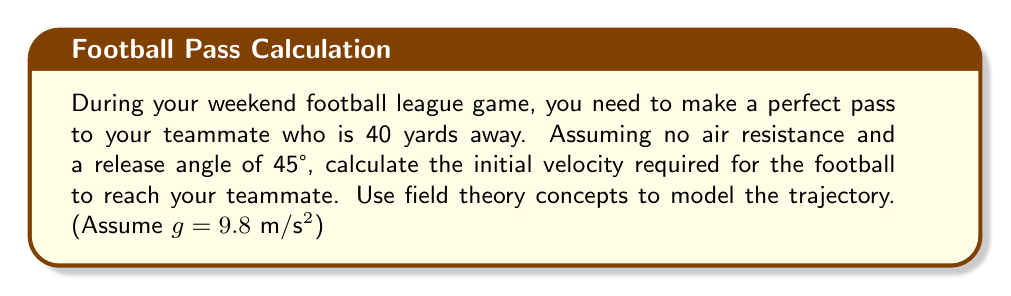Provide a solution to this math problem. Let's approach this step-by-step using field theory concepts:

1) The trajectory of the football can be modeled as a projectile motion in a uniform gravitational field. The equations of motion are:

   $$x(t) = v_0 \cos(\theta) t$$
   $$y(t) = v_0 \sin(\theta) t - \frac{1}{2}gt^2$$

   Where $v_0$ is the initial velocity, $\theta$ is the launch angle, and $t$ is time.

2) We're given that $\theta = 45°$ and the horizontal distance is 40 yards (36.576 meters).

3) For a 45° angle, $\cos(\theta) = \sin(\theta) = \frac{1}{\sqrt{2}}$

4) We need to find the time it takes for the ball to reach its target. Using the horizontal equation:

   $$36.576 = v_0 \cdot \frac{1}{\sqrt{2}} \cdot t$$

5) Solve for $t$:

   $$t = \frac{36.576 \cdot \sqrt{2}}{v_0}$$

6) Now, use this in the vertical equation. At the end point, $y(t) = 0$:

   $$0 = v_0 \cdot \frac{1}{\sqrt{2}} \cdot \frac{36.576 \cdot \sqrt{2}}{v_0} - \frac{1}{2} \cdot 9.8 \cdot (\frac{36.576 \cdot \sqrt{2}}{v_0})^2$$

7) Simplify:

   $$0 = 36.576 - \frac{1}{2} \cdot 9.8 \cdot \frac{2 \cdot 36.576^2}{v_0^2}$$

8) Solve for $v_0$:

   $$v_0^2 = 9.8 \cdot 36.576 = 358.4448$$
   $$v_0 = \sqrt{358.4448} \approx 18.93 \text{ m/s}$$

9) Convert to mph:

   $$18.93 \text{ m/s} \cdot \frac{3600 \text{ s}}{1 \text{ hr}} \cdot \frac{1 \text{ mile}}{1609.34 \text{ m}} \approx 42.33 \text{ mph}$$
Answer: 42.33 mph 